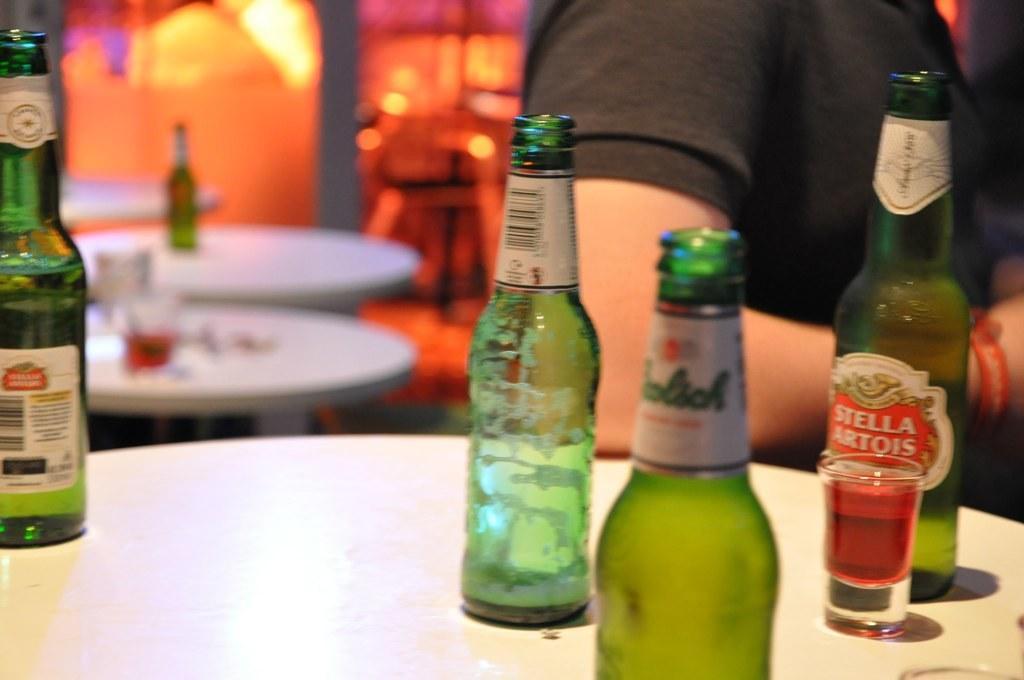Please provide a concise description of this image. In this image we can see four green color bottles with labels and a glass with drink in it are placed on the table. In the background we can see a person wearing black color t shirt and few tables 